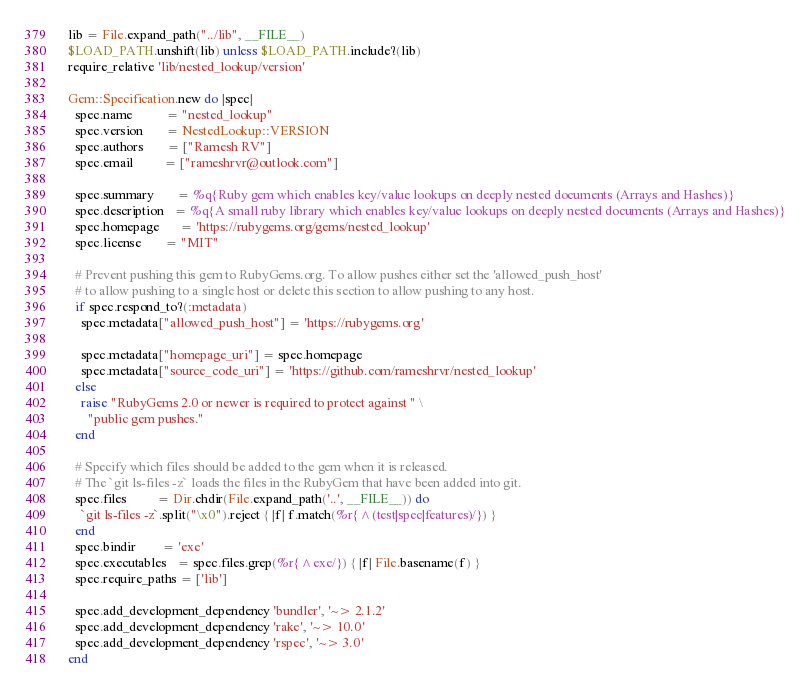<code> <loc_0><loc_0><loc_500><loc_500><_Ruby_>
lib = File.expand_path("../lib", __FILE__)
$LOAD_PATH.unshift(lib) unless $LOAD_PATH.include?(lib)
require_relative 'lib/nested_lookup/version'

Gem::Specification.new do |spec|
  spec.name          = "nested_lookup"
  spec.version       = NestedLookup::VERSION
  spec.authors       = ["Ramesh RV"]
  spec.email         = ["rameshrvr@outlook.com"]

  spec.summary       = %q{Ruby gem which enables key/value lookups on deeply nested documents (Arrays and Hashes)}
  spec.description   = %q{A small ruby library which enables key/value lookups on deeply nested documents (Arrays and Hashes)}
  spec.homepage      = 'https://rubygems.org/gems/nested_lookup'
  spec.license       = "MIT"

  # Prevent pushing this gem to RubyGems.org. To allow pushes either set the 'allowed_push_host'
  # to allow pushing to a single host or delete this section to allow pushing to any host.
  if spec.respond_to?(:metadata)
    spec.metadata["allowed_push_host"] = 'https://rubygems.org'

    spec.metadata["homepage_uri"] = spec.homepage
    spec.metadata["source_code_uri"] = 'https://github.com/rameshrvr/nested_lookup'
  else
    raise "RubyGems 2.0 or newer is required to protect against " \
      "public gem pushes."
  end

  # Specify which files should be added to the gem when it is released.
  # The `git ls-files -z` loads the files in the RubyGem that have been added into git.
  spec.files         = Dir.chdir(File.expand_path('..', __FILE__)) do
    `git ls-files -z`.split("\x0").reject { |f| f.match(%r{^(test|spec|features)/}) }
  end
  spec.bindir        = 'exe'
  spec.executables   = spec.files.grep(%r{^exe/}) { |f| File.basename(f) }
  spec.require_paths = ['lib']

  spec.add_development_dependency 'bundler', '~> 2.1.2'
  spec.add_development_dependency 'rake', '~> 10.0'
  spec.add_development_dependency 'rspec', '~> 3.0'
end
</code> 